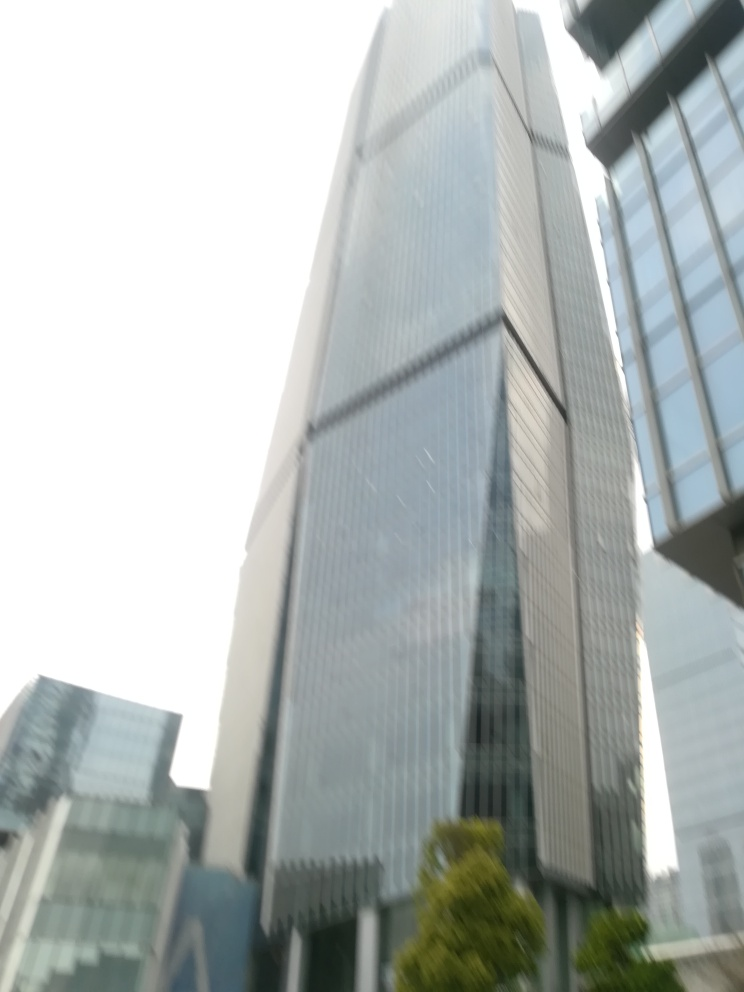What might be the environmental impacts of buildings like the one in the image? Buildings like this can have several environmental impacts including high energy consumption due to lighting, heating, and cooling needs. The glass facade, while aesthetically appealing, can contribute to the urban heat island effect. However, if designed with sustainability in mind, it could include features like energy-efficient glazing, green roofing, or solar panels to mitigate these effects. 